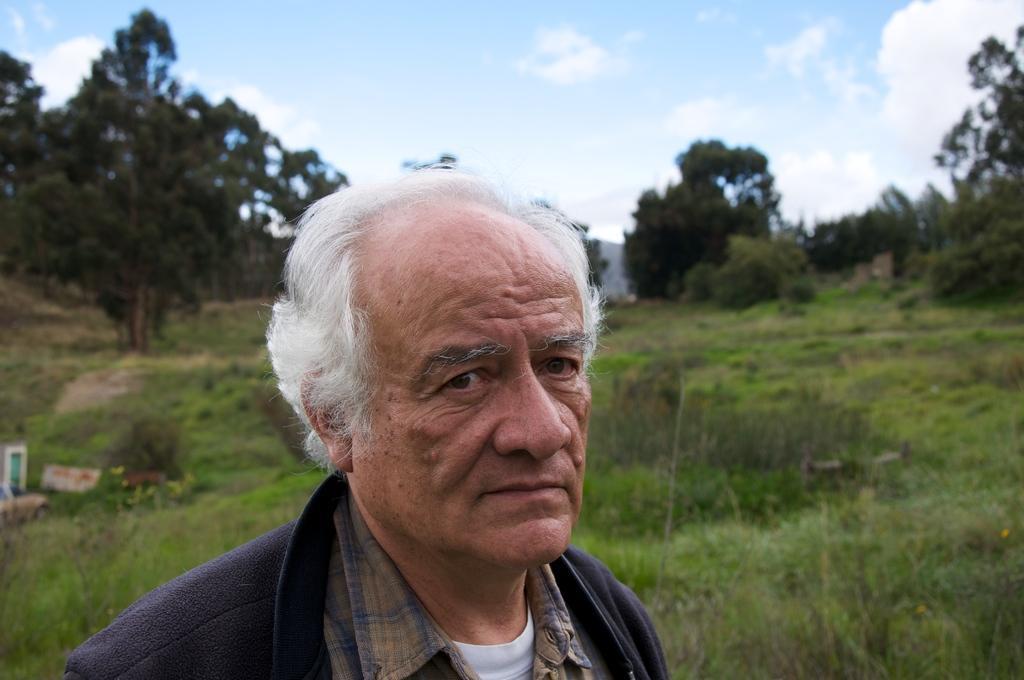Can you describe this image briefly? In this image we can see a person and behind him we can also see trees, plants and sky. 